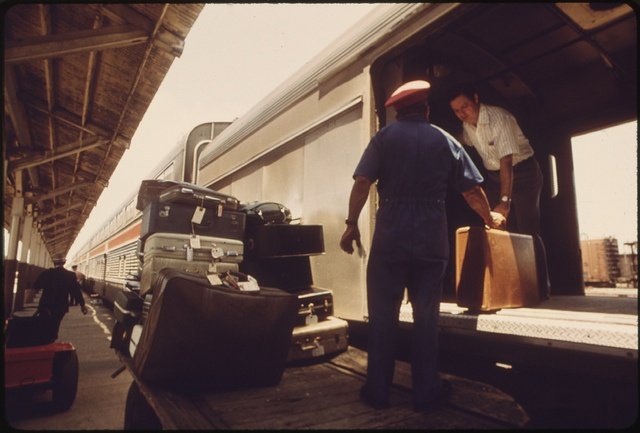Describe the objects in this image and their specific colors. I can see train in black, tan, and beige tones, people in black, maroon, and gray tones, suitcase in black, maroon, and brown tones, people in black, maroon, tan, and gray tones, and suitcase in black, brown, maroon, and gray tones in this image. 